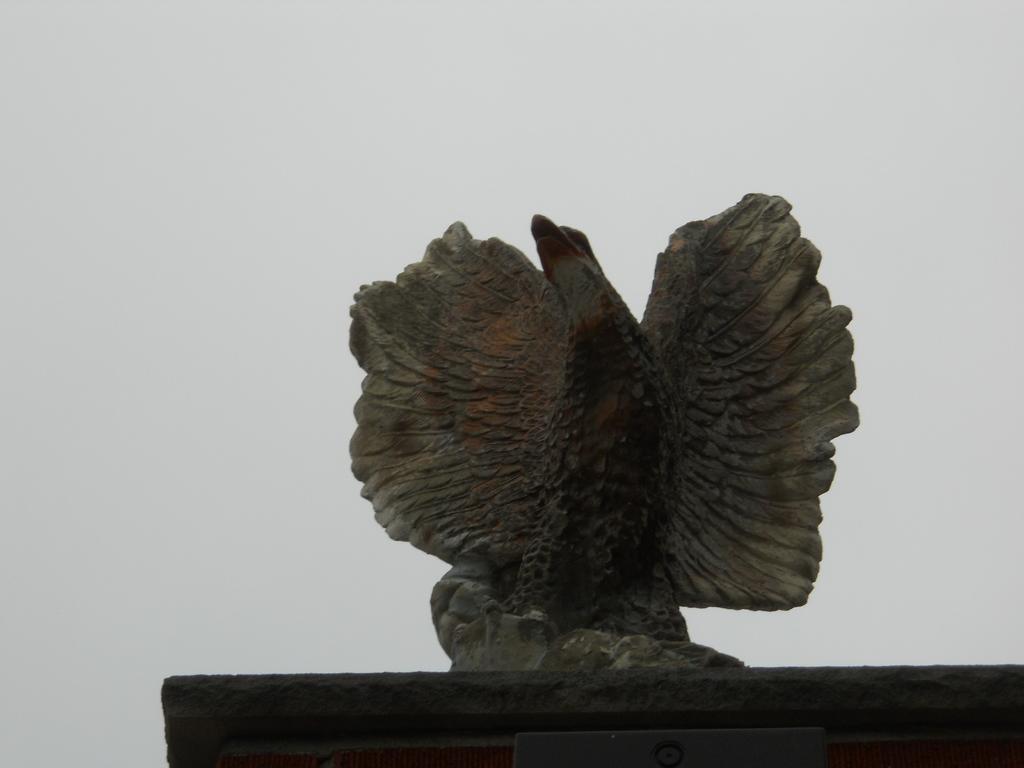Can you describe this image briefly? In this picture there is a statue in the front and the sky is cloudy. 